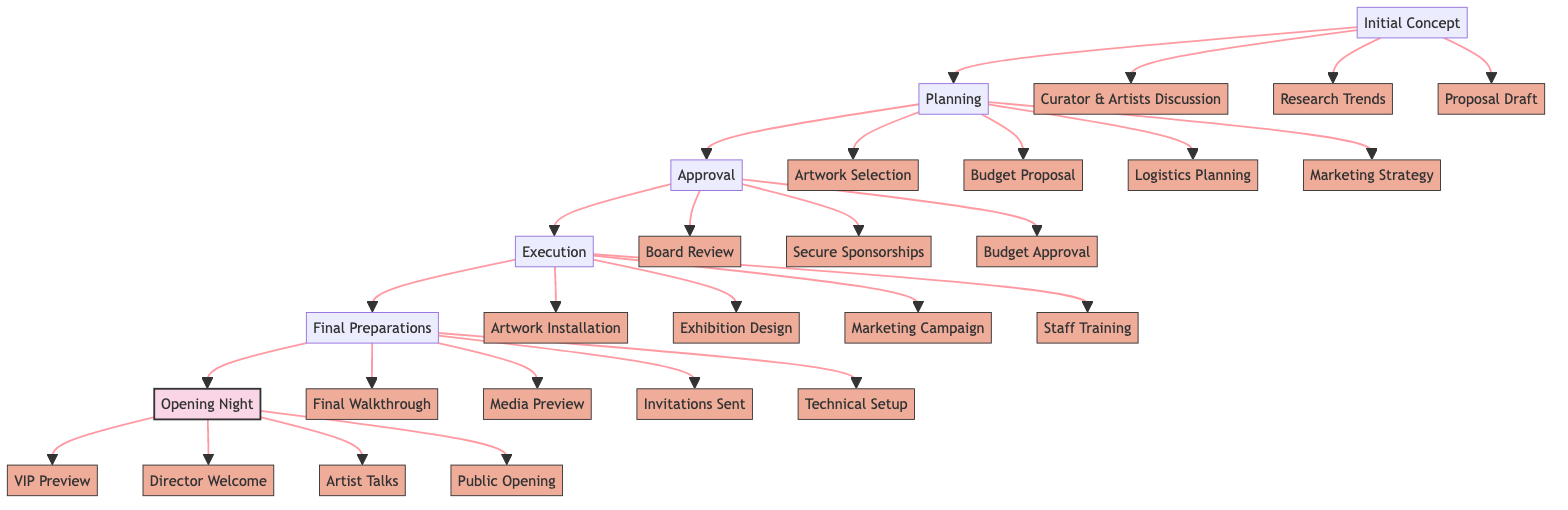what is the first step in the exhibition process? The diagram indicates that the first step in the exhibition process is "Initial Concept." This is clearly labeled as the starting point of the pathway flow.
Answer: Initial Concept how many elements are involved in the "Planning" stage? In the "Planning" stage, four elements are listed: Artwork Selection, Budget Proposal, Logistics Planning, and Marketing Strategy. Counting these elements shows that there are four in total.
Answer: 4 what follows the "Approval" step? The step that follows "Approval" in the pathway is "Execution." The arrows in the diagram show the direction of flow, leading clearly from Approval to Execution.
Answer: Execution which team is responsible for the initial marketing strategy? The initial marketing strategy is indicated to be the responsibility of the PR Team as per the elements outlined in the "Planning" stage.
Answer: PR Team how many total steps are outlined in the pathway? The pathway describes a total of six distinct steps, including Initial Concept, Planning, Approval, Execution, Final Preparations, and Opening Night. Counting these steps gives the total.
Answer: 6 what are the elements listed under the "Final Preparations" stage? The elements in the "Final Preparations" stage include: Final Walkthrough, Media Preview, Invitations Sent, and Technical Setup. These are clearly labeled under that specific stage in the diagram.
Answer: Final Walkthrough, Media Preview, Invitations Sent, Technical Setup which step includes the VIP preview and reception? The "Opening Night" step includes the VIP Preview and Reception, as this element is categorized within that stage in the diagram.
Answer: Opening Night which stage precedes "Final Preparations"? The stage that precedes "Final Preparations" is "Execution." This can be determined by tracing the arrows in the flowchart from Final Preparations back to the previous step.
Answer: Execution 